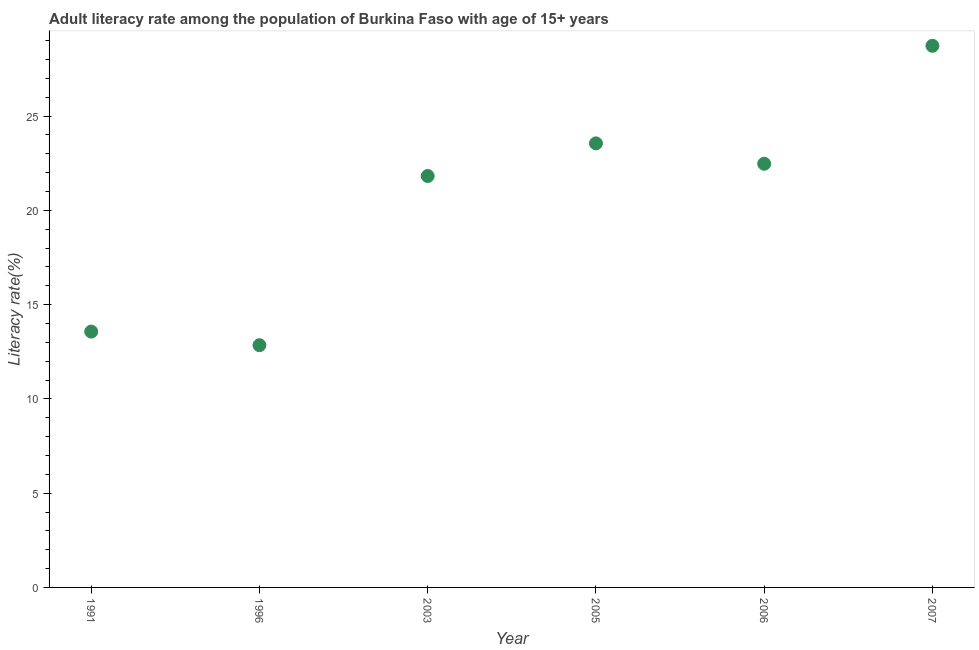What is the adult literacy rate in 1991?
Your answer should be very brief. 13.57. Across all years, what is the maximum adult literacy rate?
Your answer should be compact. 28.73. Across all years, what is the minimum adult literacy rate?
Provide a short and direct response. 12.85. In which year was the adult literacy rate maximum?
Make the answer very short. 2007. In which year was the adult literacy rate minimum?
Your answer should be compact. 1996. What is the sum of the adult literacy rate?
Provide a short and direct response. 123. What is the difference between the adult literacy rate in 1991 and 2006?
Ensure brevity in your answer.  -8.9. What is the average adult literacy rate per year?
Offer a very short reply. 20.5. What is the median adult literacy rate?
Keep it short and to the point. 22.15. In how many years, is the adult literacy rate greater than 14 %?
Offer a very short reply. 4. Do a majority of the years between 2003 and 1996 (inclusive) have adult literacy rate greater than 21 %?
Your answer should be compact. No. What is the ratio of the adult literacy rate in 1991 to that in 2003?
Provide a succinct answer. 0.62. Is the difference between the adult literacy rate in 1991 and 2007 greater than the difference between any two years?
Provide a short and direct response. No. What is the difference between the highest and the second highest adult literacy rate?
Your answer should be very brief. 5.18. Is the sum of the adult literacy rate in 2005 and 2007 greater than the maximum adult literacy rate across all years?
Provide a short and direct response. Yes. What is the difference between the highest and the lowest adult literacy rate?
Provide a succinct answer. 15.88. In how many years, is the adult literacy rate greater than the average adult literacy rate taken over all years?
Give a very brief answer. 4. Does the adult literacy rate monotonically increase over the years?
Provide a short and direct response. No. How many years are there in the graph?
Keep it short and to the point. 6. Are the values on the major ticks of Y-axis written in scientific E-notation?
Provide a short and direct response. No. What is the title of the graph?
Your response must be concise. Adult literacy rate among the population of Burkina Faso with age of 15+ years. What is the label or title of the X-axis?
Your response must be concise. Year. What is the label or title of the Y-axis?
Provide a short and direct response. Literacy rate(%). What is the Literacy rate(%) in 1991?
Ensure brevity in your answer.  13.57. What is the Literacy rate(%) in 1996?
Your answer should be compact. 12.85. What is the Literacy rate(%) in 2003?
Offer a very short reply. 21.82. What is the Literacy rate(%) in 2005?
Make the answer very short. 23.55. What is the Literacy rate(%) in 2006?
Your answer should be compact. 22.47. What is the Literacy rate(%) in 2007?
Make the answer very short. 28.73. What is the difference between the Literacy rate(%) in 1991 and 1996?
Provide a short and direct response. 0.72. What is the difference between the Literacy rate(%) in 1991 and 2003?
Keep it short and to the point. -8.25. What is the difference between the Literacy rate(%) in 1991 and 2005?
Provide a succinct answer. -9.98. What is the difference between the Literacy rate(%) in 1991 and 2006?
Your answer should be compact. -8.9. What is the difference between the Literacy rate(%) in 1991 and 2007?
Make the answer very short. -15.16. What is the difference between the Literacy rate(%) in 1996 and 2003?
Your answer should be very brief. -8.97. What is the difference between the Literacy rate(%) in 1996 and 2005?
Offer a terse response. -10.71. What is the difference between the Literacy rate(%) in 1996 and 2006?
Your response must be concise. -9.62. What is the difference between the Literacy rate(%) in 1996 and 2007?
Make the answer very short. -15.88. What is the difference between the Literacy rate(%) in 2003 and 2005?
Provide a short and direct response. -1.73. What is the difference between the Literacy rate(%) in 2003 and 2006?
Offer a terse response. -0.65. What is the difference between the Literacy rate(%) in 2003 and 2007?
Offer a terse response. -6.91. What is the difference between the Literacy rate(%) in 2005 and 2006?
Keep it short and to the point. 1.08. What is the difference between the Literacy rate(%) in 2005 and 2007?
Provide a short and direct response. -5.18. What is the difference between the Literacy rate(%) in 2006 and 2007?
Offer a very short reply. -6.26. What is the ratio of the Literacy rate(%) in 1991 to that in 1996?
Provide a short and direct response. 1.06. What is the ratio of the Literacy rate(%) in 1991 to that in 2003?
Your answer should be very brief. 0.62. What is the ratio of the Literacy rate(%) in 1991 to that in 2005?
Ensure brevity in your answer.  0.58. What is the ratio of the Literacy rate(%) in 1991 to that in 2006?
Provide a succinct answer. 0.6. What is the ratio of the Literacy rate(%) in 1991 to that in 2007?
Provide a short and direct response. 0.47. What is the ratio of the Literacy rate(%) in 1996 to that in 2003?
Your answer should be very brief. 0.59. What is the ratio of the Literacy rate(%) in 1996 to that in 2005?
Your response must be concise. 0.55. What is the ratio of the Literacy rate(%) in 1996 to that in 2006?
Your response must be concise. 0.57. What is the ratio of the Literacy rate(%) in 1996 to that in 2007?
Provide a succinct answer. 0.45. What is the ratio of the Literacy rate(%) in 2003 to that in 2005?
Offer a very short reply. 0.93. What is the ratio of the Literacy rate(%) in 2003 to that in 2007?
Ensure brevity in your answer.  0.76. What is the ratio of the Literacy rate(%) in 2005 to that in 2006?
Your response must be concise. 1.05. What is the ratio of the Literacy rate(%) in 2005 to that in 2007?
Your response must be concise. 0.82. What is the ratio of the Literacy rate(%) in 2006 to that in 2007?
Offer a very short reply. 0.78. 